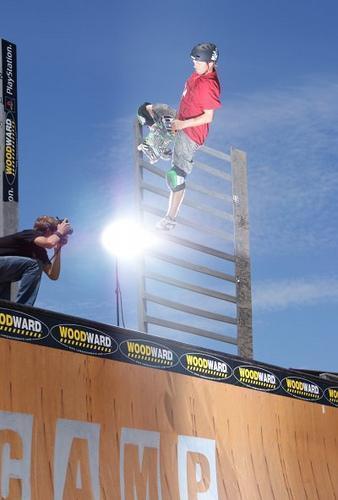How many people are there?
Give a very brief answer. 2. How many oranges with barcode stickers?
Give a very brief answer. 0. 